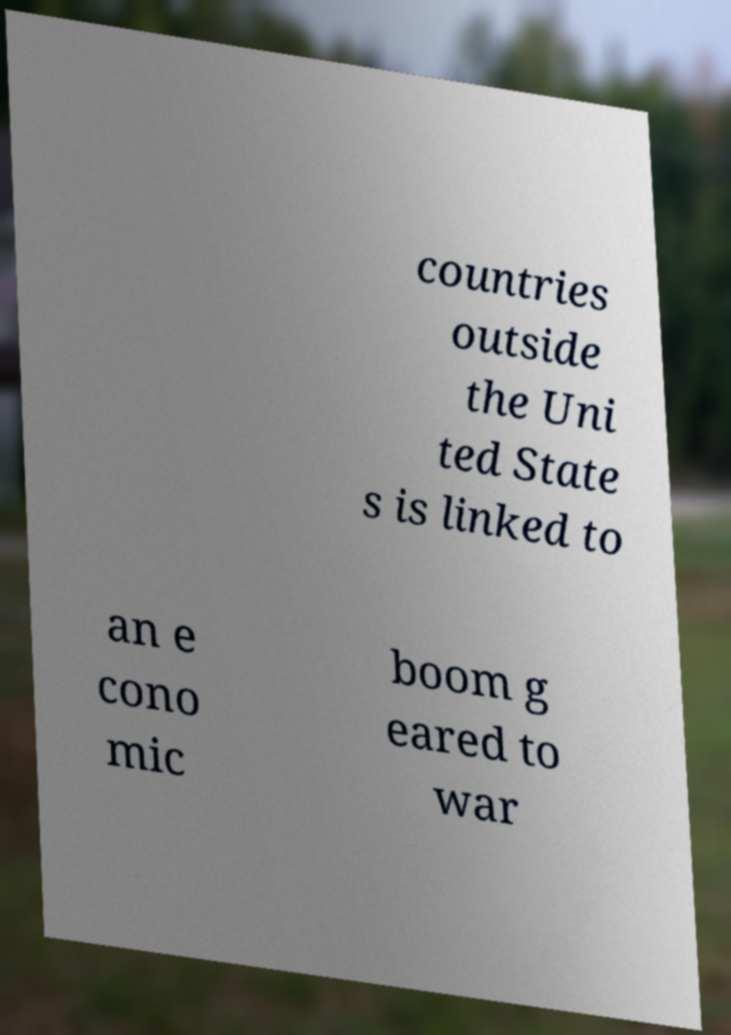Can you accurately transcribe the text from the provided image for me? countries outside the Uni ted State s is linked to an e cono mic boom g eared to war 